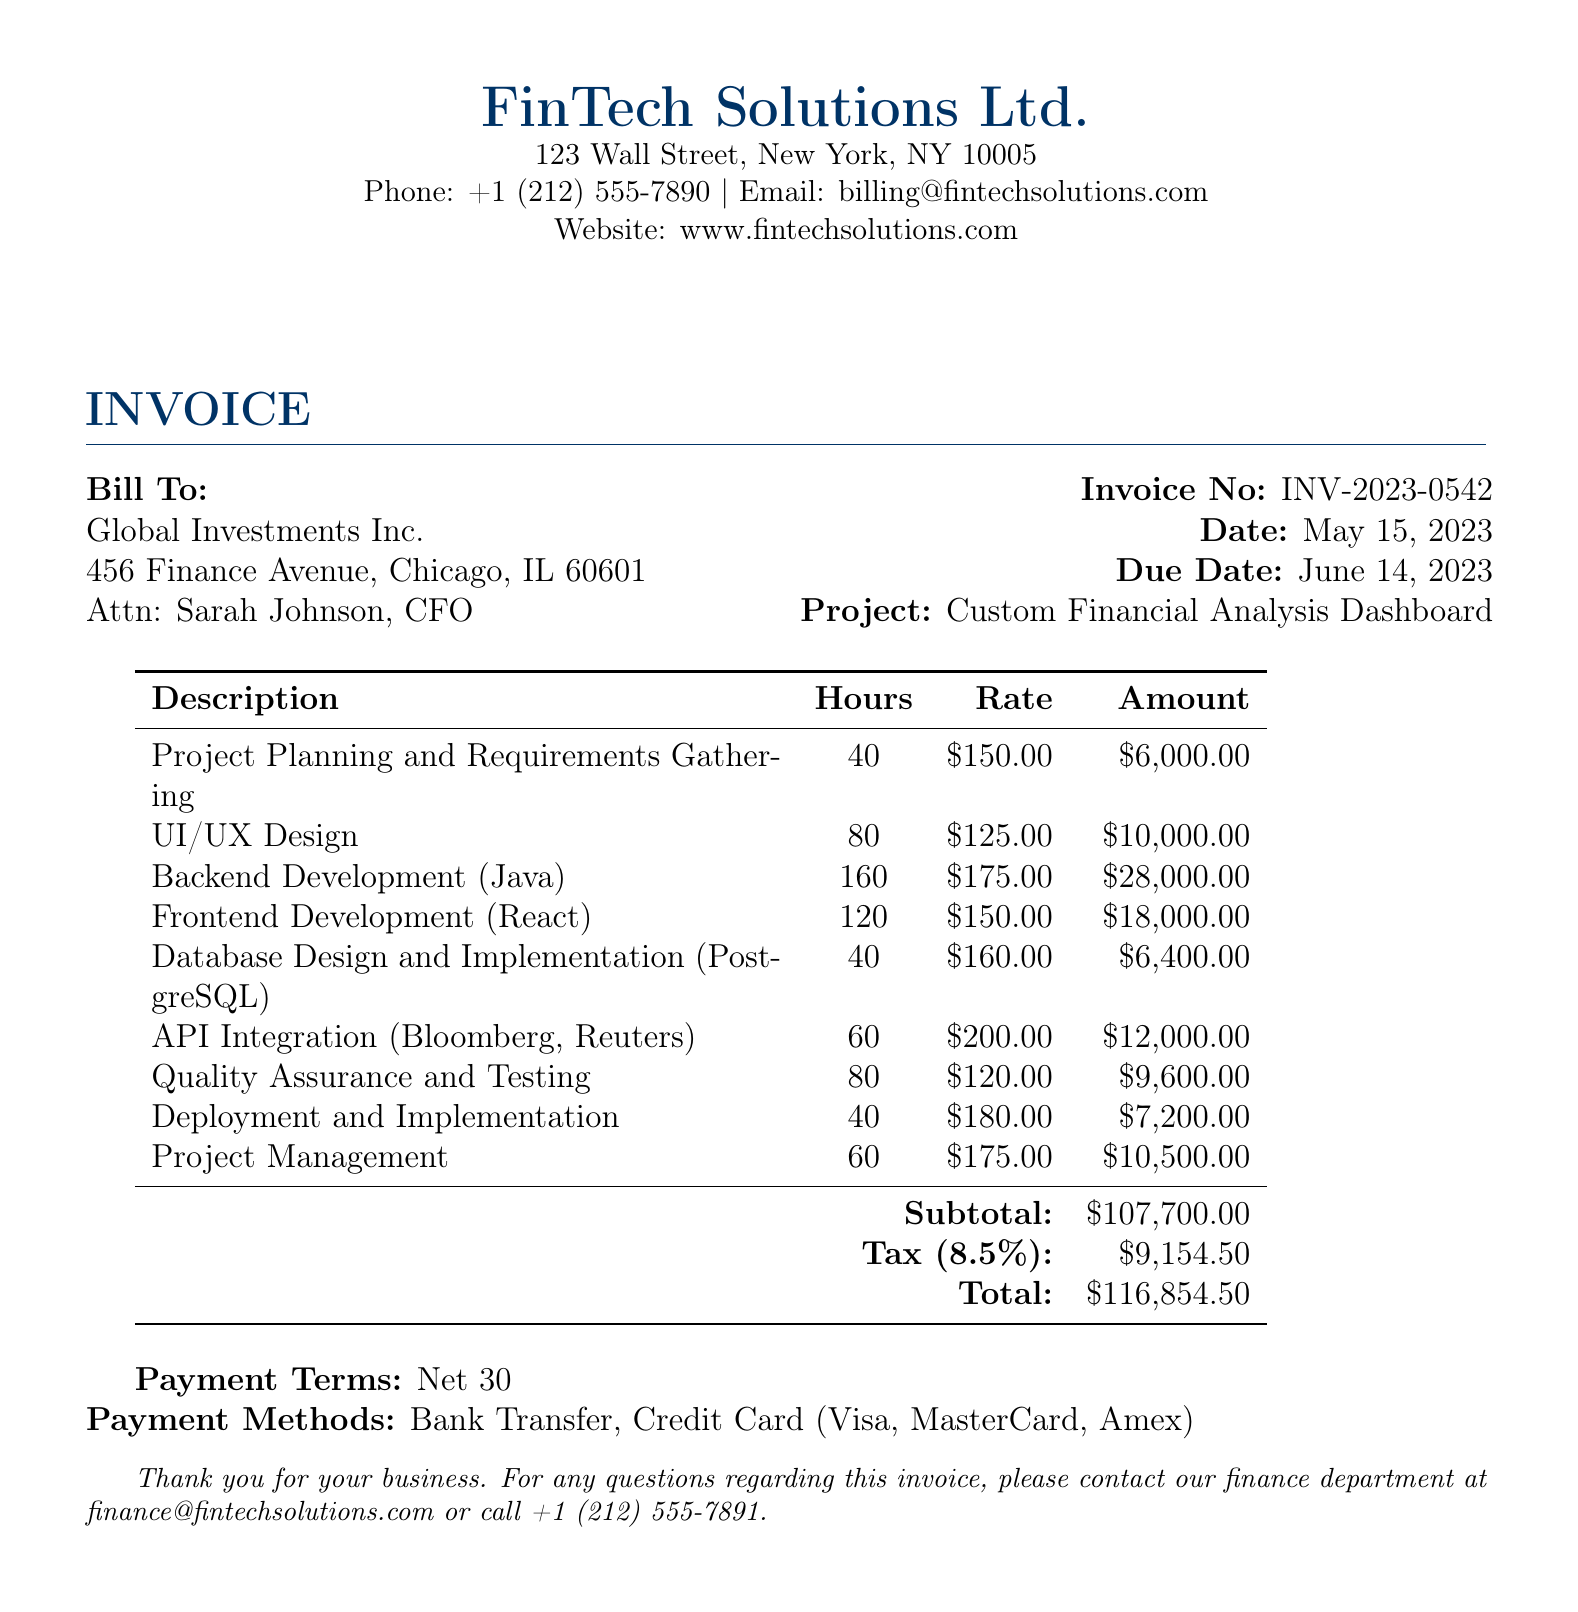What is the invoice number? The invoice number is listed in the document as INV-2023-0542.
Answer: INV-2023-0542 What is the total amount due? The total amount due is calculated in the document as $116,854.50.
Answer: $116,854.50 What is the due date for the invoice? The due date for the invoice is specified as June 14, 2023.
Answer: June 14, 2023 Who is the contact person for the billed company? The contact person for Global Investments Inc. is Sarah Johnson, CFO.
Answer: Sarah Johnson How many hours were allocated for Backend Development? The document indicates that 160 hours were allocated for Backend Development.
Answer: 160 What percentage is the tax applied to the subtotal? The tax rate mentioned in the document is 8.5%.
Answer: 8.5% What was the amount charged for UI/UX Design? The amount charged for UI/UX Design is stated as $10,000.00.
Answer: $10,000.00 What payment terms are specified in the invoice? The payment terms specified are Net 30.
Answer: Net 30 How many hours were allocated for Quality Assurance and Testing? The document shows that 80 hours were allocated for Quality Assurance and Testing.
Answer: 80 